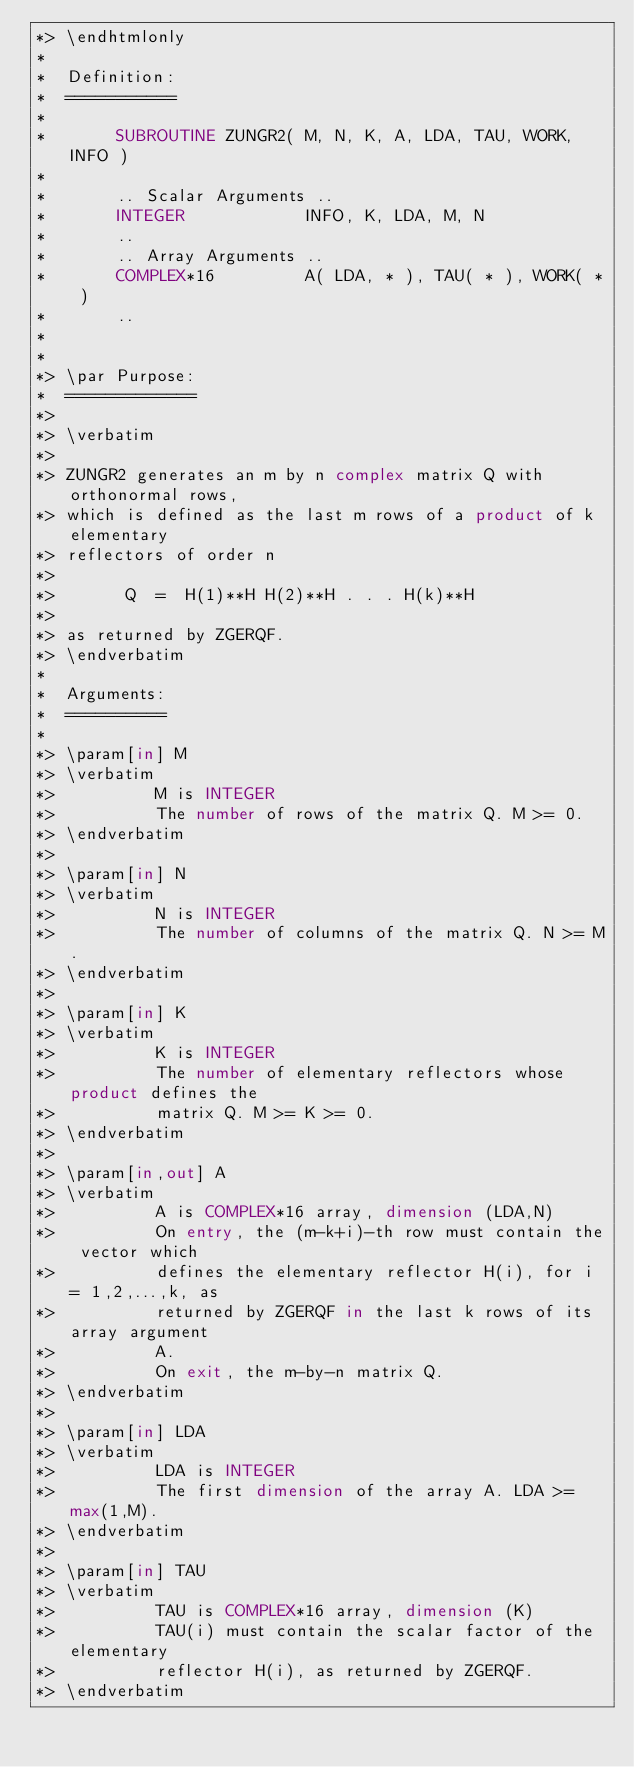<code> <loc_0><loc_0><loc_500><loc_500><_FORTRAN_>*> \endhtmlonly
*
*  Definition:
*  ===========
*
*       SUBROUTINE ZUNGR2( M, N, K, A, LDA, TAU, WORK, INFO )
*
*       .. Scalar Arguments ..
*       INTEGER            INFO, K, LDA, M, N
*       ..
*       .. Array Arguments ..
*       COMPLEX*16         A( LDA, * ), TAU( * ), WORK( * )
*       ..
*
*
*> \par Purpose:
*  =============
*>
*> \verbatim
*>
*> ZUNGR2 generates an m by n complex matrix Q with orthonormal rows,
*> which is defined as the last m rows of a product of k elementary
*> reflectors of order n
*>
*>       Q  =  H(1)**H H(2)**H . . . H(k)**H
*>
*> as returned by ZGERQF.
*> \endverbatim
*
*  Arguments:
*  ==========
*
*> \param[in] M
*> \verbatim
*>          M is INTEGER
*>          The number of rows of the matrix Q. M >= 0.
*> \endverbatim
*>
*> \param[in] N
*> \verbatim
*>          N is INTEGER
*>          The number of columns of the matrix Q. N >= M.
*> \endverbatim
*>
*> \param[in] K
*> \verbatim
*>          K is INTEGER
*>          The number of elementary reflectors whose product defines the
*>          matrix Q. M >= K >= 0.
*> \endverbatim
*>
*> \param[in,out] A
*> \verbatim
*>          A is COMPLEX*16 array, dimension (LDA,N)
*>          On entry, the (m-k+i)-th row must contain the vector which
*>          defines the elementary reflector H(i), for i = 1,2,...,k, as
*>          returned by ZGERQF in the last k rows of its array argument
*>          A.
*>          On exit, the m-by-n matrix Q.
*> \endverbatim
*>
*> \param[in] LDA
*> \verbatim
*>          LDA is INTEGER
*>          The first dimension of the array A. LDA >= max(1,M).
*> \endverbatim
*>
*> \param[in] TAU
*> \verbatim
*>          TAU is COMPLEX*16 array, dimension (K)
*>          TAU(i) must contain the scalar factor of the elementary
*>          reflector H(i), as returned by ZGERQF.
*> \endverbatim</code> 